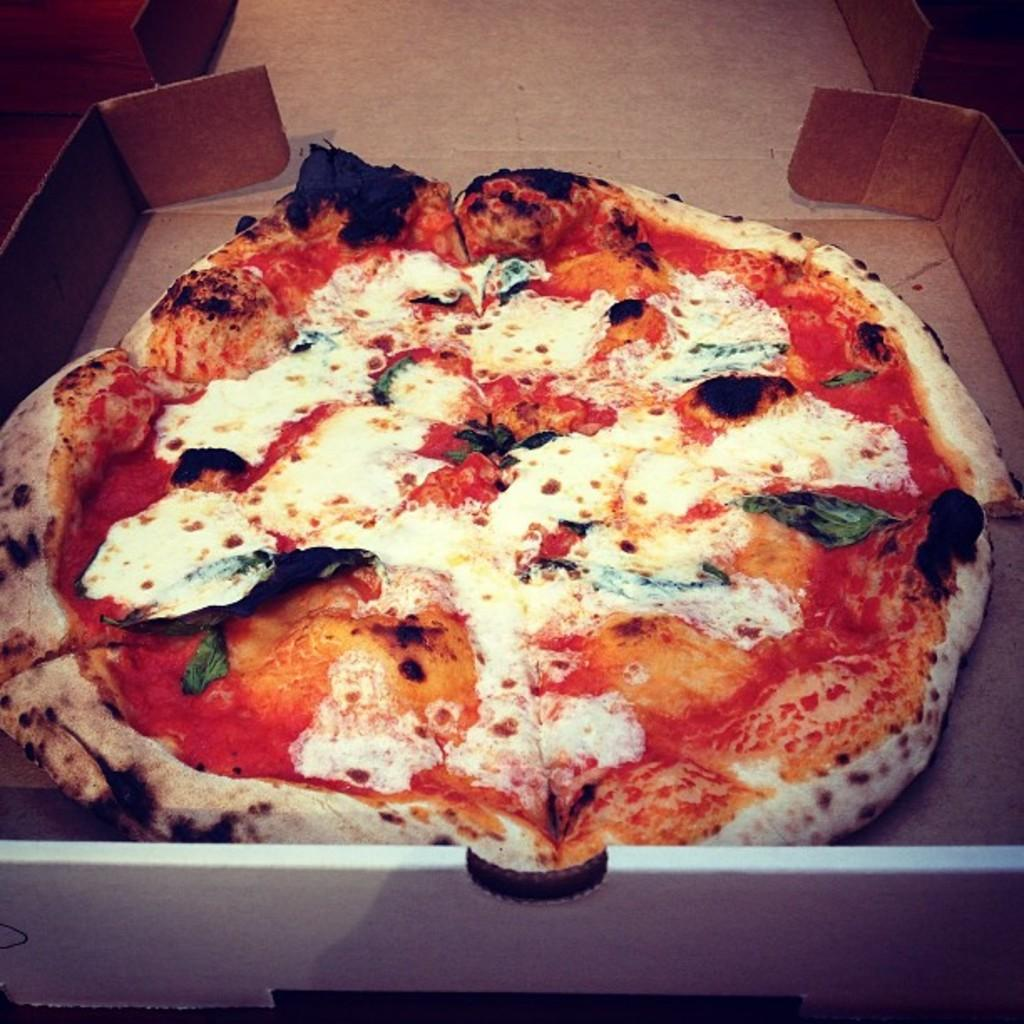What type of food is shown in the image? There is a pizza in the image. How is the pizza being stored or transported? The pizza is in a box. What type of tiger can be seen interacting with the pizza in the image? There is no tiger present in the image; it only features a pizza in a box. What type of fuel is used to power the pizza in the image? Pizzas do not require fuel to function, as they are a type of food. 